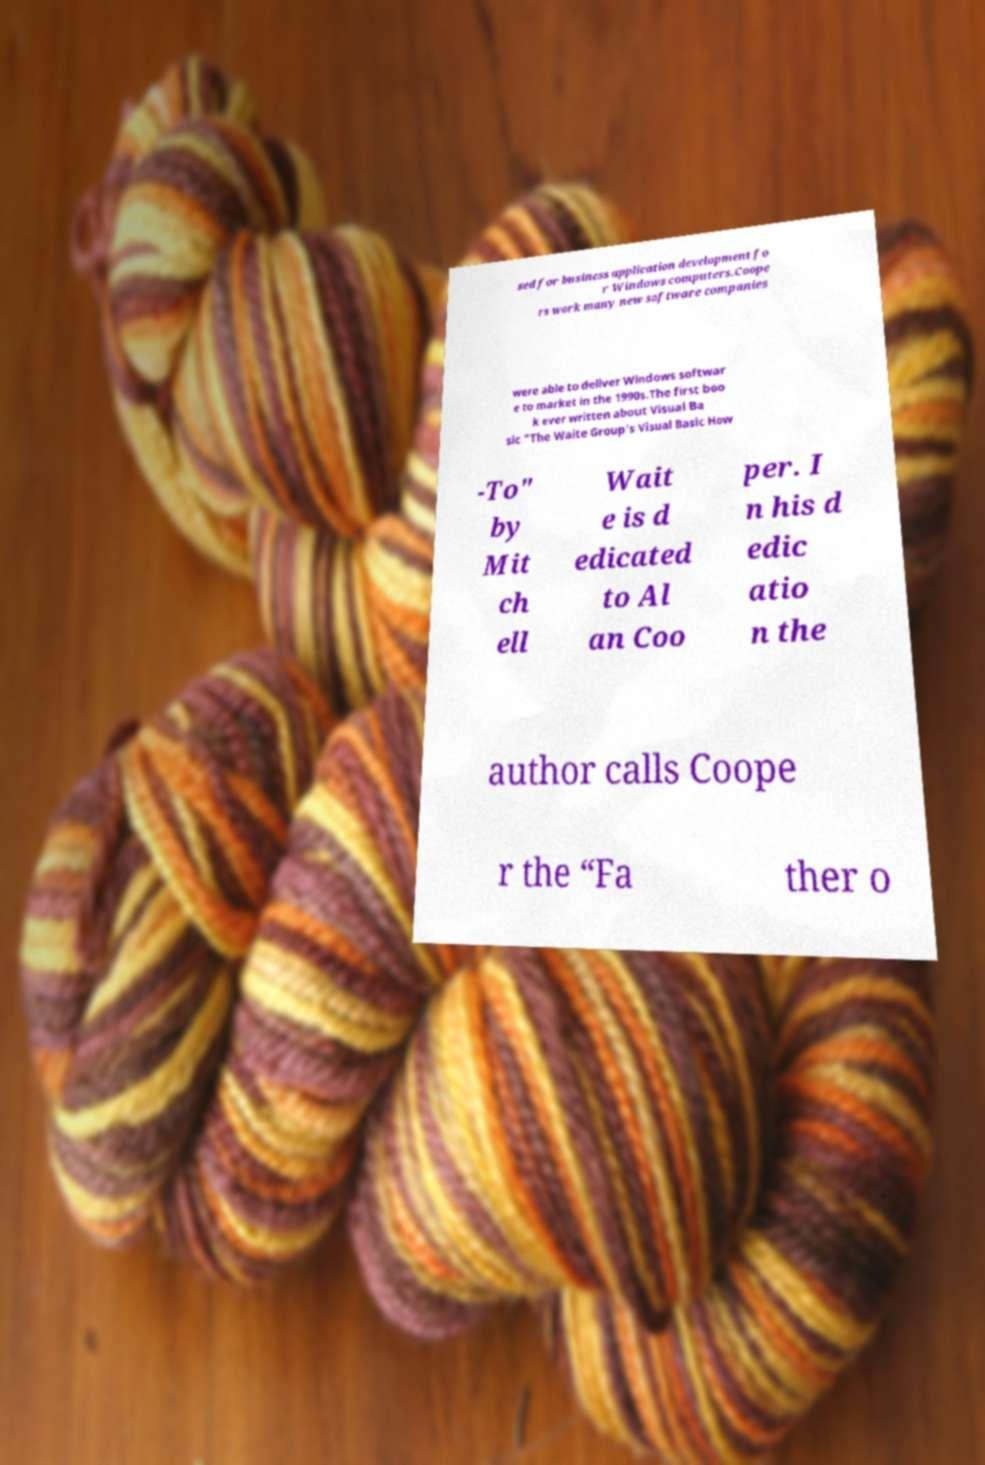Can you read and provide the text displayed in the image?This photo seems to have some interesting text. Can you extract and type it out for me? sed for business application development fo r Windows computers.Coope rs work many new software companies were able to deliver Windows softwar e to market in the 1990s.The first boo k ever written about Visual Ba sic "The Waite Group’s Visual Basic How -To" by Mit ch ell Wait e is d edicated to Al an Coo per. I n his d edic atio n the author calls Coope r the “Fa ther o 